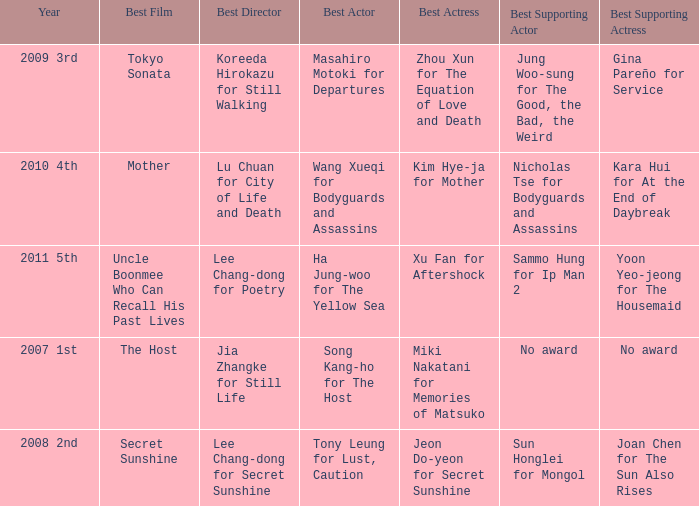Name the year for sammo hung for ip man 2 2011 5th. 